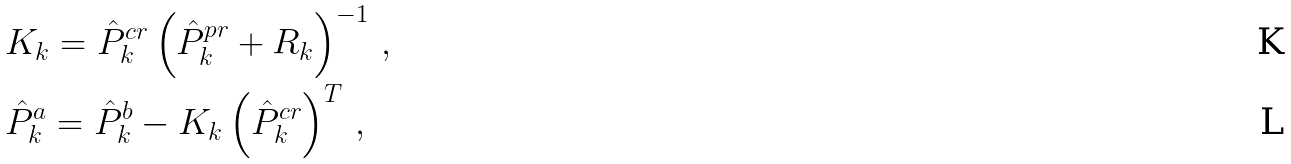Convert formula to latex. <formula><loc_0><loc_0><loc_500><loc_500>& K _ { k } = \hat { P } ^ { c r } _ { k } \left ( \hat { P } ^ { p r } _ { k } + R _ { k } \right ) ^ { - 1 } \, , \\ & \hat { P } _ { k } ^ { a } = \hat { P } _ { k } ^ { b } - K _ { k } \left ( \hat { P } ^ { c r } _ { k } \right ) ^ { T } \, ,</formula> 